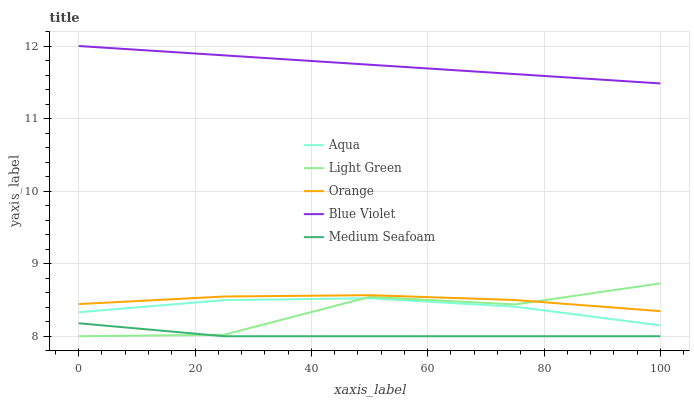Does Aqua have the minimum area under the curve?
Answer yes or no. No. Does Aqua have the maximum area under the curve?
Answer yes or no. No. Is Aqua the smoothest?
Answer yes or no. No. Is Aqua the roughest?
Answer yes or no. No. Does Aqua have the lowest value?
Answer yes or no. No. Does Aqua have the highest value?
Answer yes or no. No. Is Medium Seafoam less than Aqua?
Answer yes or no. Yes. Is Aqua greater than Medium Seafoam?
Answer yes or no. Yes. Does Medium Seafoam intersect Aqua?
Answer yes or no. No. 